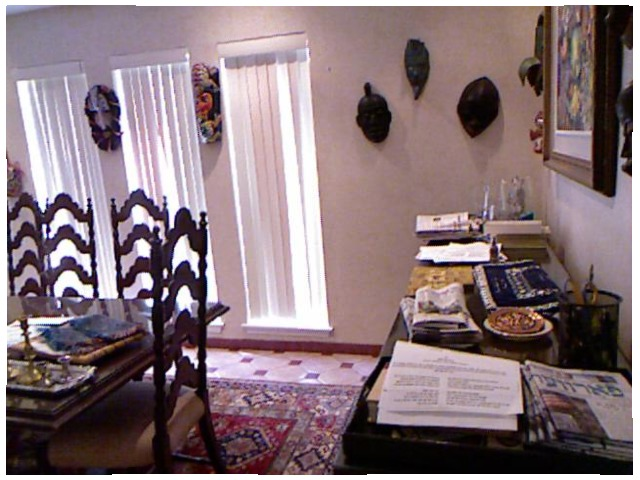<image>
Can you confirm if the newspaper is on the table? Yes. Looking at the image, I can see the newspaper is positioned on top of the table, with the table providing support. Is there a mask behind the chair? No. The mask is not behind the chair. From this viewpoint, the mask appears to be positioned elsewhere in the scene. Is there a chair to the left of the table? No. The chair is not to the left of the table. From this viewpoint, they have a different horizontal relationship. Is there a shade in the window? Yes. The shade is contained within or inside the window, showing a containment relationship. 